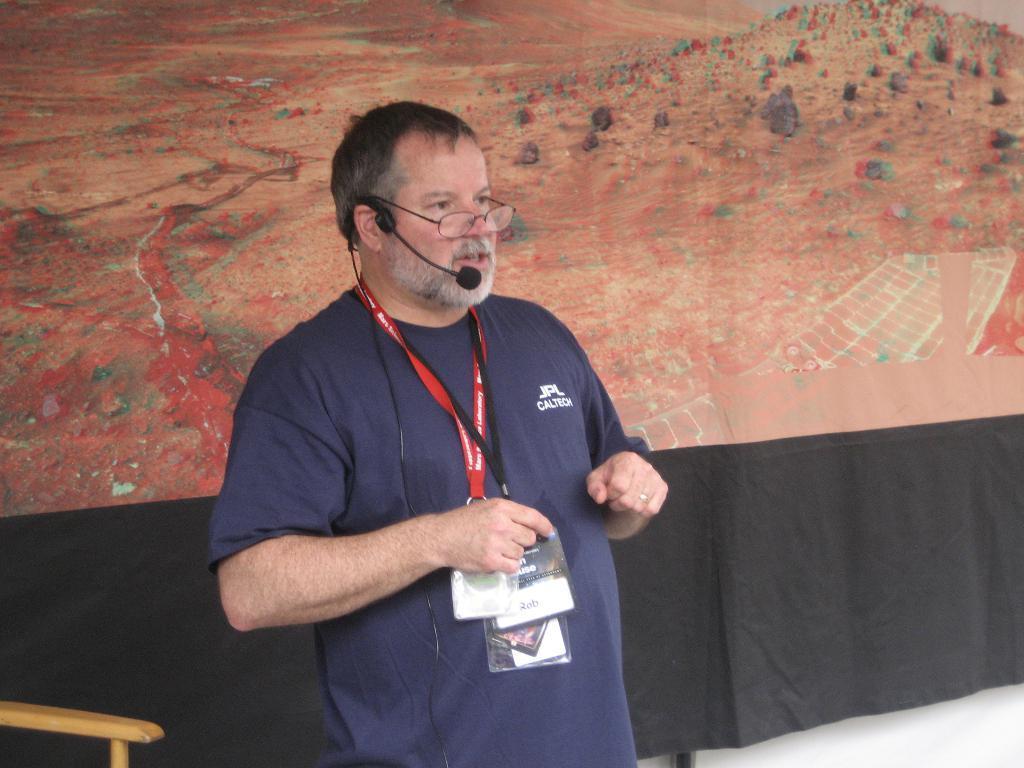Could you give a brief overview of what you see in this image? In this picture I can observe a man. He is wearing blue color T shirt and tags in his neck. The man is wearing spectacles and a mic. In the background I can observe a cloth which is in black and red color. 